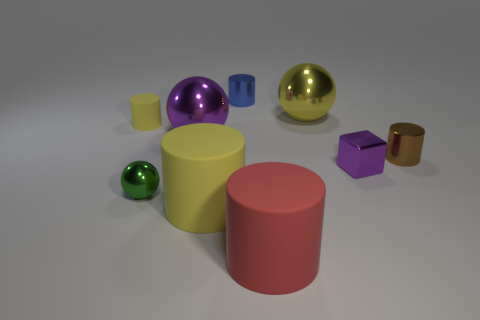Are there any other things that are the same shape as the small purple thing?
Your answer should be compact. No. Does the large red rubber object have the same shape as the blue object?
Provide a short and direct response. Yes. How many purple things are the same size as the green metallic thing?
Provide a short and direct response. 1. Is the number of large red matte things left of the red rubber cylinder less than the number of blocks?
Ensure brevity in your answer.  Yes. There is a rubber cylinder in front of the large matte cylinder on the left side of the tiny blue metallic object; how big is it?
Your answer should be compact. Large. How many objects are shiny things or large red matte cylinders?
Offer a terse response. 7. Is there a metallic sphere of the same color as the small rubber object?
Offer a very short reply. Yes. Are there fewer small purple objects than rubber blocks?
Make the answer very short. No. How many objects are small yellow rubber cylinders or metal spheres that are behind the big purple sphere?
Keep it short and to the point. 2. Is there a large object made of the same material as the tiny brown cylinder?
Your answer should be compact. Yes. 